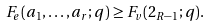Convert formula to latex. <formula><loc_0><loc_0><loc_500><loc_500>F _ { e } ( a _ { 1 } , \dots , a _ { r } ; q ) \geq F _ { v } ( 2 _ { R - 1 } ; q ) .</formula> 